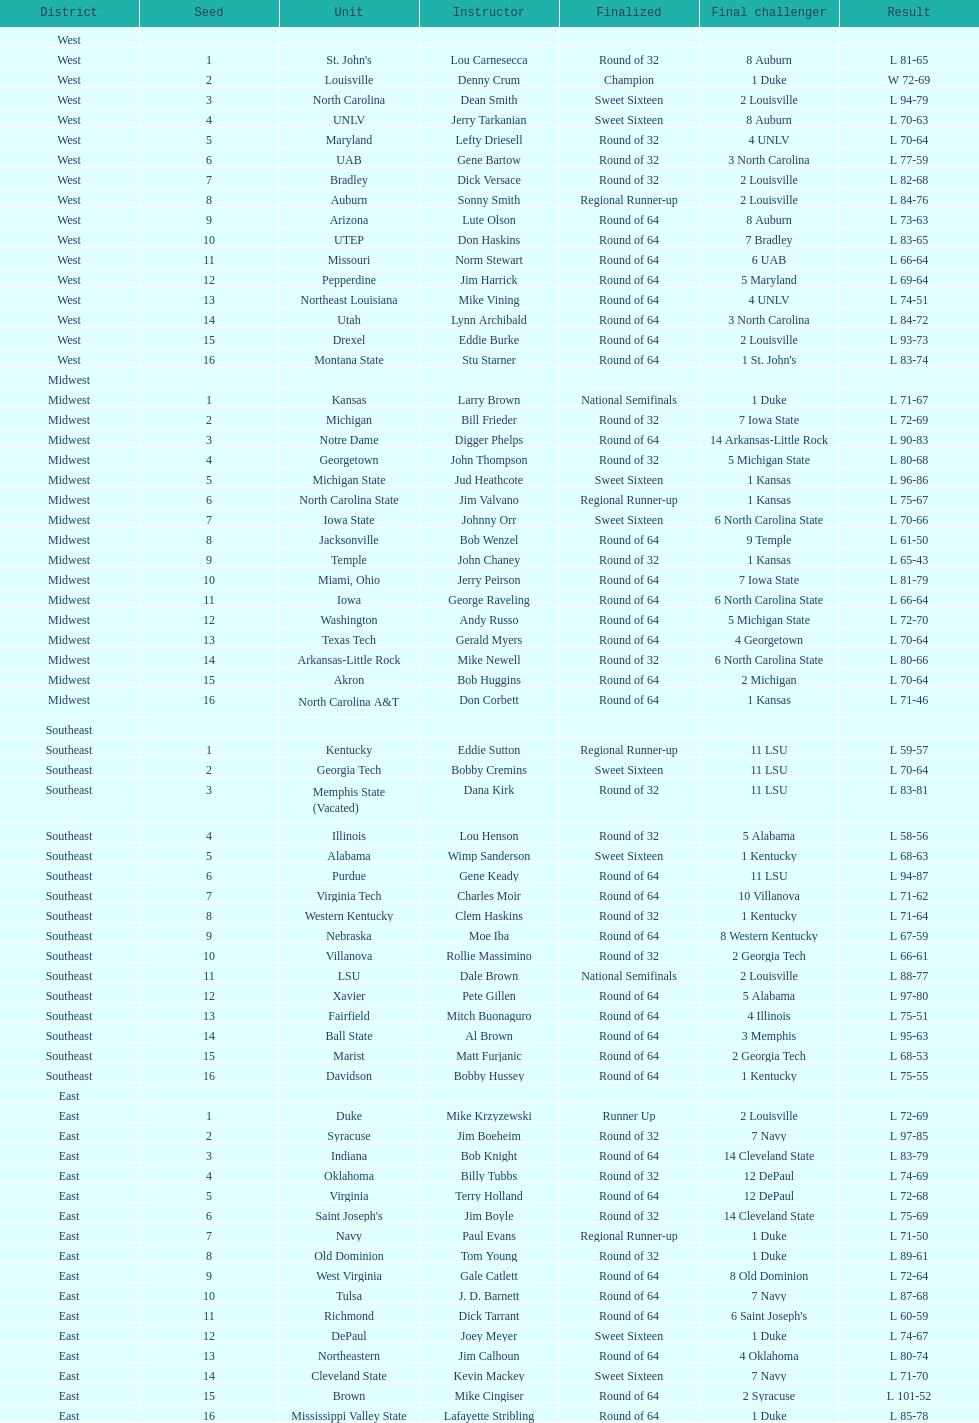How many 1 seeds are there? 4. 